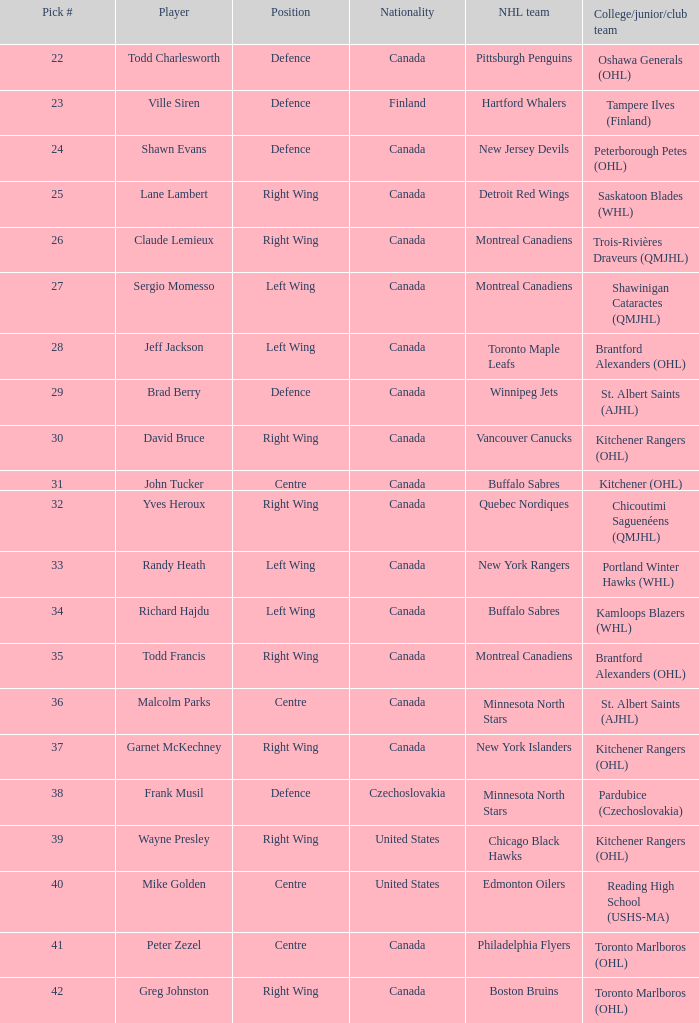What is the nationality when the player is randy heath? Canada. 